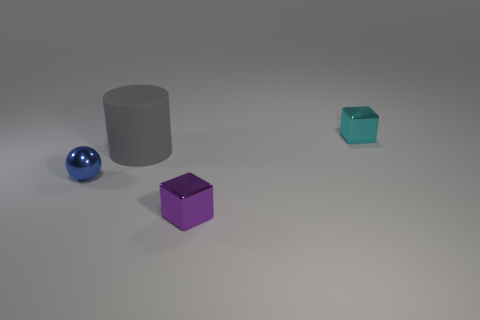Add 2 green metal things. How many objects exist? 6 Subtract all cylinders. How many objects are left? 3 Subtract all big gray shiny cubes. Subtract all tiny blue shiny things. How many objects are left? 3 Add 3 blocks. How many blocks are left? 5 Add 2 purple shiny cubes. How many purple shiny cubes exist? 3 Subtract 0 brown cylinders. How many objects are left? 4 